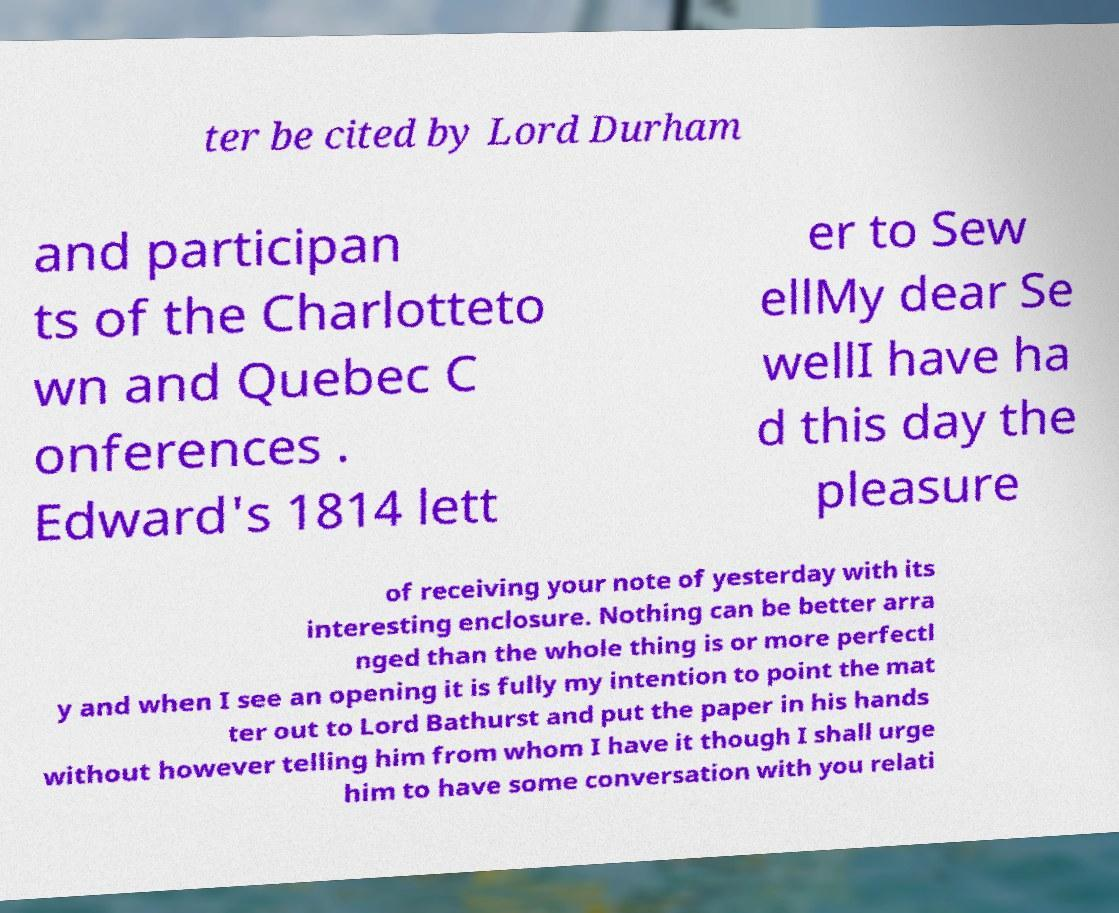Please read and relay the text visible in this image. What does it say? ter be cited by Lord Durham and participan ts of the Charlotteto wn and Quebec C onferences . Edward's 1814 lett er to Sew ellMy dear Se wellI have ha d this day the pleasure of receiving your note of yesterday with its interesting enclosure. Nothing can be better arra nged than the whole thing is or more perfectl y and when I see an opening it is fully my intention to point the mat ter out to Lord Bathurst and put the paper in his hands without however telling him from whom I have it though I shall urge him to have some conversation with you relati 